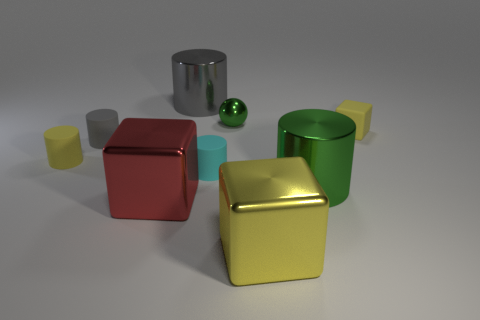Subtract all red blocks. How many blocks are left? 2 Subtract all yellow cylinders. How many cylinders are left? 4 Subtract all blocks. How many objects are left? 6 Subtract 2 cubes. How many cubes are left? 1 Subtract all yellow cylinders. Subtract all yellow cubes. How many cylinders are left? 4 Subtract all red balls. How many red blocks are left? 1 Subtract all cylinders. Subtract all big brown metal cylinders. How many objects are left? 4 Add 1 tiny green shiny things. How many tiny green shiny things are left? 2 Add 6 big brown things. How many big brown things exist? 6 Subtract 0 red balls. How many objects are left? 9 